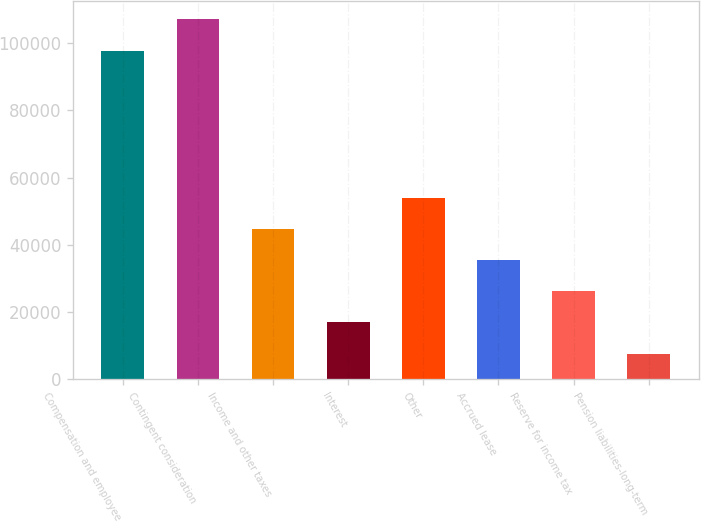Convert chart. <chart><loc_0><loc_0><loc_500><loc_500><bar_chart><fcel>Compensation and employee<fcel>Contingent consideration<fcel>Income and other taxes<fcel>Interest<fcel>Other<fcel>Accrued lease<fcel>Reserve for income tax<fcel>Pension liabilities-long-term<nl><fcel>97747<fcel>107001<fcel>44730.4<fcel>16968.1<fcel>53984.5<fcel>35476.3<fcel>26222.2<fcel>7714<nl></chart> 